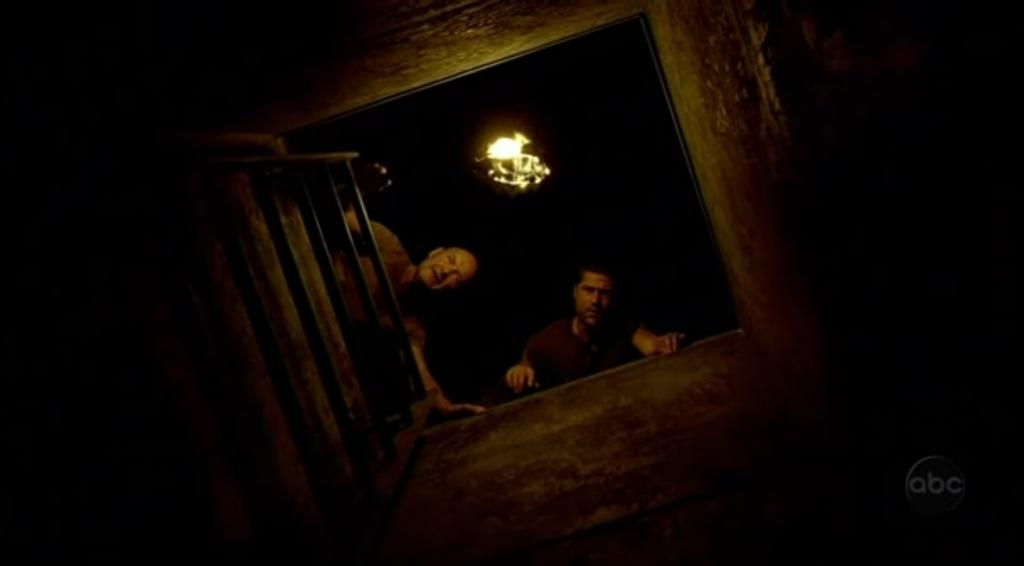What is the main object in the image? There is a tank in the image. What else can be seen in the image besides the tank? There is a ladder and men in the image. Is there any source of light in the image? Yes, there is a light in the image. Can you see a kitten climbing the ladder in the image? No, there is no kitten present in the image. What type of connection is established between the tank and the ladder in the image? There is no specific connection between the tank and the ladder mentioned in the image; they are simply two separate objects. 